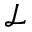Convert formula to latex. <formula><loc_0><loc_0><loc_500><loc_500>\mathcal { L }</formula> 